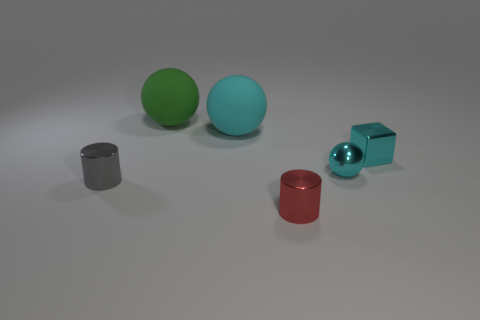Is the size of the cyan metal sphere the same as the cylinder that is to the left of the green thing?
Your response must be concise. Yes. There is a small metallic object that is in front of the cylinder on the left side of the big cyan object; what color is it?
Make the answer very short. Red. How many other objects are the same color as the block?
Give a very brief answer. 2. How big is the red object?
Offer a terse response. Small. Are there more spheres that are in front of the green rubber thing than cyan rubber things to the right of the metallic block?
Ensure brevity in your answer.  Yes. How many tiny cyan cubes are behind the sphere that is behind the big cyan ball?
Offer a terse response. 0. Do the cyan thing that is behind the tiny metallic block and the red metal thing have the same shape?
Offer a terse response. No. What material is the large cyan object that is the same shape as the big green rubber thing?
Make the answer very short. Rubber. How many green balls have the same size as the gray metallic object?
Keep it short and to the point. 0. What color is the object that is in front of the small metallic cube and left of the tiny red shiny cylinder?
Your answer should be very brief. Gray. 